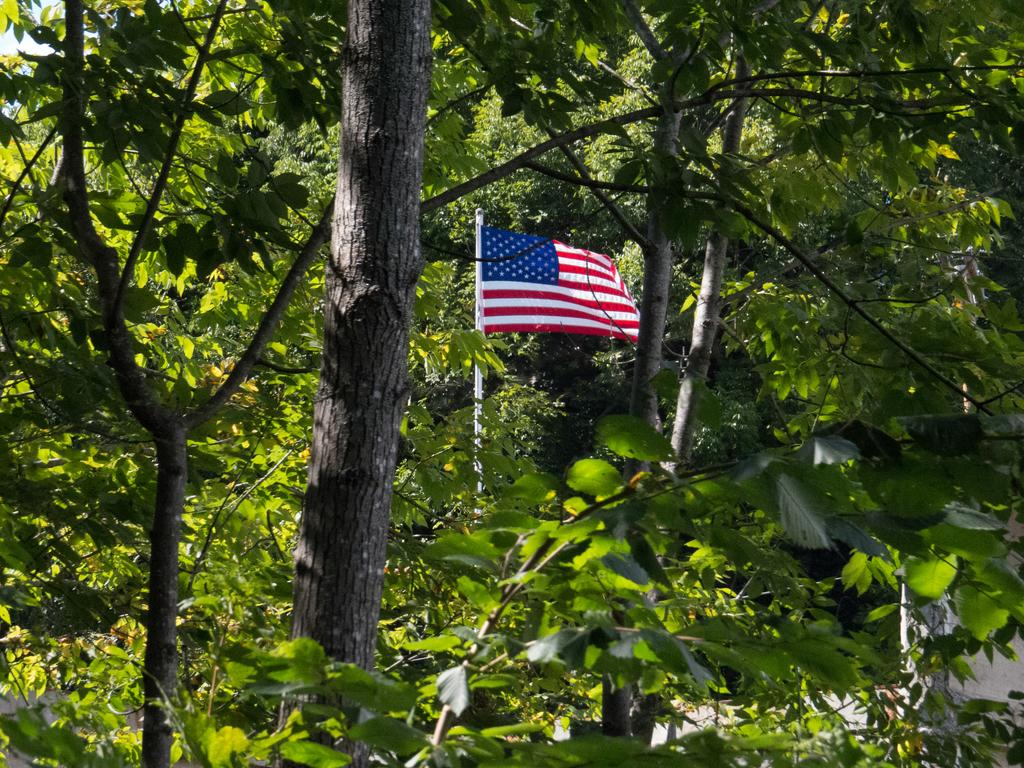What can be seen in the image that represents a symbol or country? There is a flag in the image. Where is the flag located in relation to other elements in the image? The flag is near to the plants. What type of natural environment is depicted in the image? There are many trees in the image. What architectural feature can be seen in the bottom right of the image? There is a structure visible in the bottom right of the image. What is visible in the top left corner of the image? The sky and clouds are visible in the top left corner of the image. What type of tail can be seen on the turkey in the image? There is no turkey present in the image, so there is no tail to observe. 